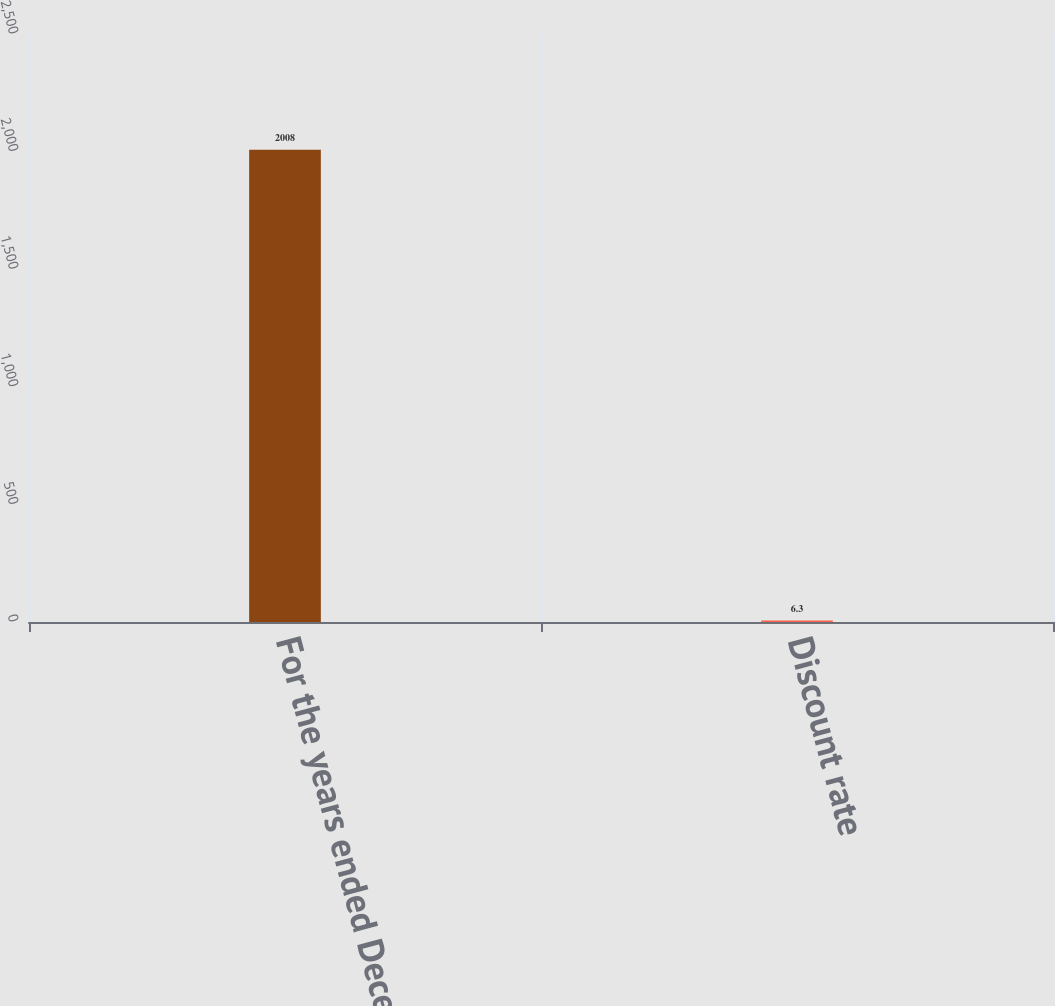Convert chart. <chart><loc_0><loc_0><loc_500><loc_500><bar_chart><fcel>For the years ended December<fcel>Discount rate<nl><fcel>2008<fcel>6.3<nl></chart> 